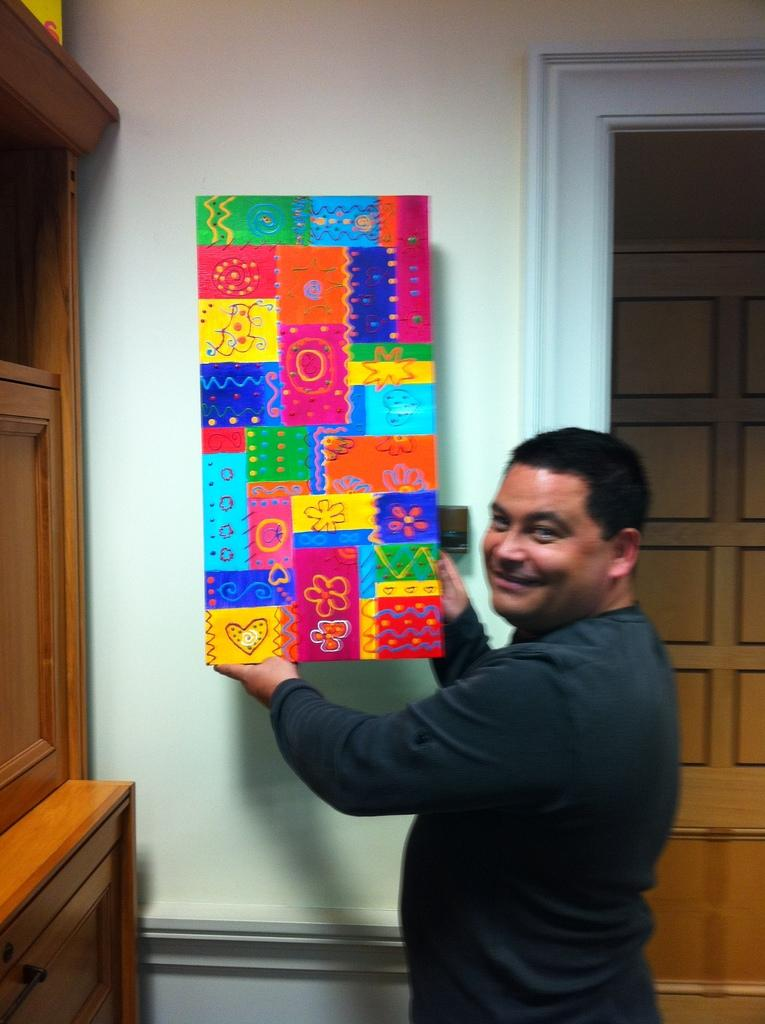What is the main subject of the image? There is a man in the image. What is the man doing in the image? The man is holding an object and standing while smiling. Can you describe the background of the image? There is a cupboard on the left side of the image, a wall in the background, and a door in the background. What type of pipe can be seen in the man's hand in the image? There is no pipe present in the man's hand or in the image. 